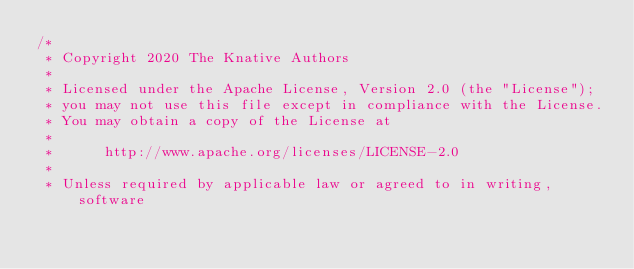<code> <loc_0><loc_0><loc_500><loc_500><_Go_>/*
 * Copyright 2020 The Knative Authors
 *
 * Licensed under the Apache License, Version 2.0 (the "License");
 * you may not use this file except in compliance with the License.
 * You may obtain a copy of the License at
 *
 *      http://www.apache.org/licenses/LICENSE-2.0
 *
 * Unless required by applicable law or agreed to in writing, software</code> 